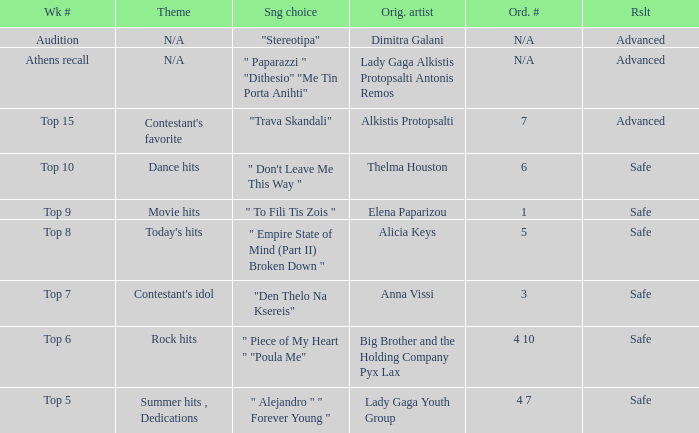Which artists have order number 6? Thelma Houston. 